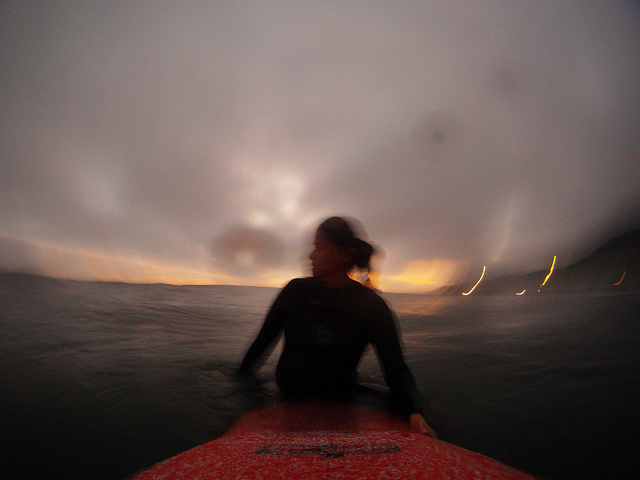What technical considerations might have been taken into account while capturing this photo? This photo appears to be taken with a slower shutter speed, as indicated by the motion blur evident both in the subject and the background lights. A wide-angle lens might have been used to capture the expansive view of the ocean and horizon. The camera's ISO sensitivity was likely increased to adapt to the low-light conditions of sunset, allowing the photographer to capture more details despite the diminishing light. How does this affect the visual storytelling of this scene? The use of slow shutter speed and wide-angle lens enhances the photo’s storytelling by portraying a sense of movement and expansiveness. It conveys a feeling of being in the moment, reflecting the surfer's perspective as they navigate through the waters. The technique emphasizes the adventurous and dynamic elements of surfing, especially under challenging light conditions, and heightens the emotional impact of the image. 